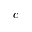<formula> <loc_0><loc_0><loc_500><loc_500>c</formula> 